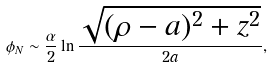Convert formula to latex. <formula><loc_0><loc_0><loc_500><loc_500>\phi _ { N } \sim \frac { \alpha } { 2 } \ln \frac { \sqrt { ( \rho - a ) ^ { 2 } + z ^ { 2 } } } { 2 a } ,</formula> 